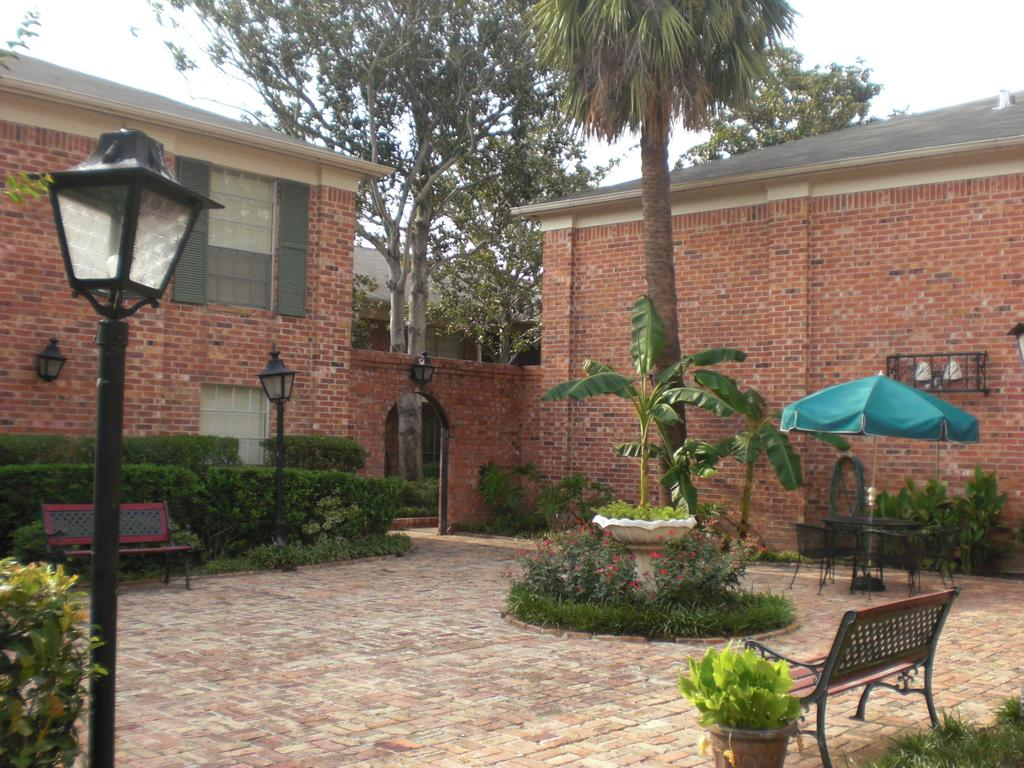What type of structures can be seen in the image? There are houses in the image. What type of vegetation is present in the image? There are trees in the image. What object is used for protection from the rain in the image? There is an umbrella in the image. What type of seating is available in the image? There are chairs and benches in the image. What type of lighting is present in the image? There are pole lights in the image. Can you tell me how many police officers are patrolling the area in the image? There is no indication of police officers in the image. What type of vegetable is being harvested in the image? There is no vegetable, specifically cabbage, present in the image. 